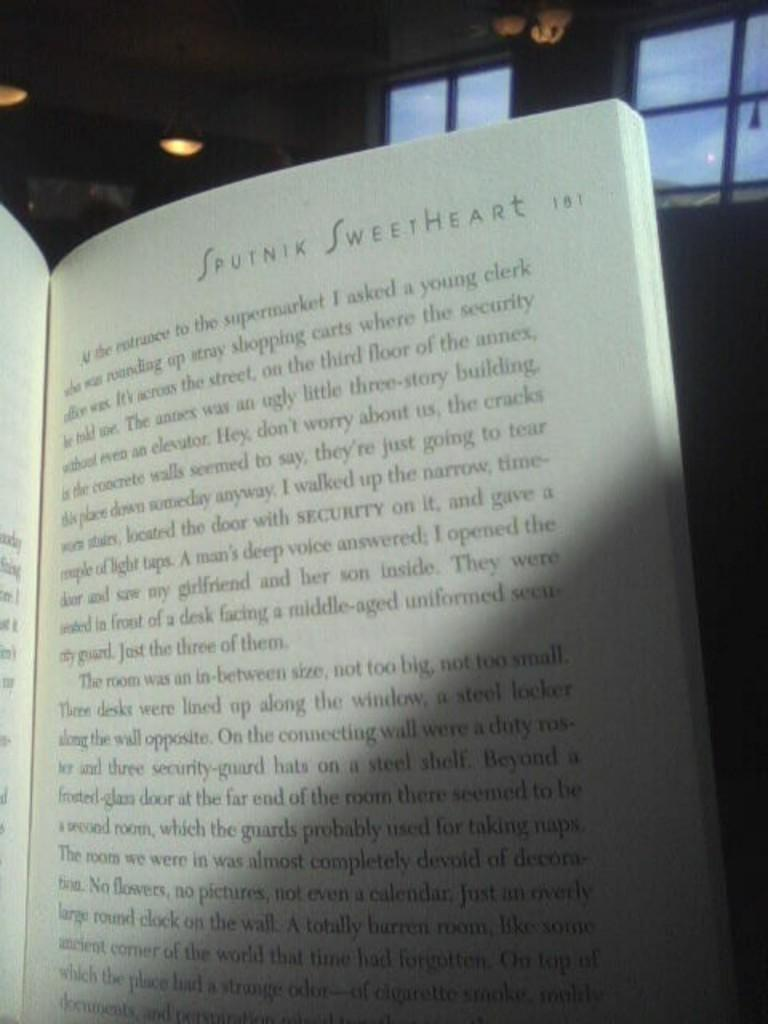<image>
Share a concise interpretation of the image provided. Reading the top of this page makes one think of their sweetheart. 